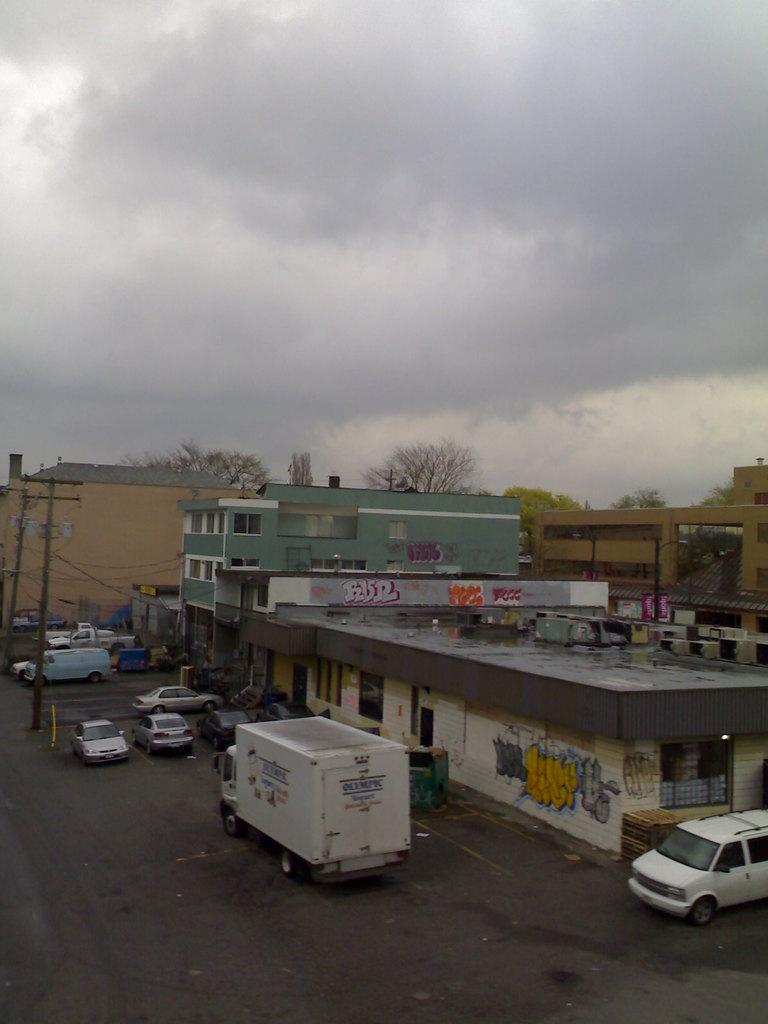What types of objects can be seen in the image? There are vehicles and buildings in the image. What is located behind the buildings? Trees are visible behind the buildings. What is visible at the top of the image? The sky is visible at the top of the image. What is the chance of a bag catching fire in the image? There is no bag or fire present in the image, so it is not possible to determine the chance of a bag catching fire. 